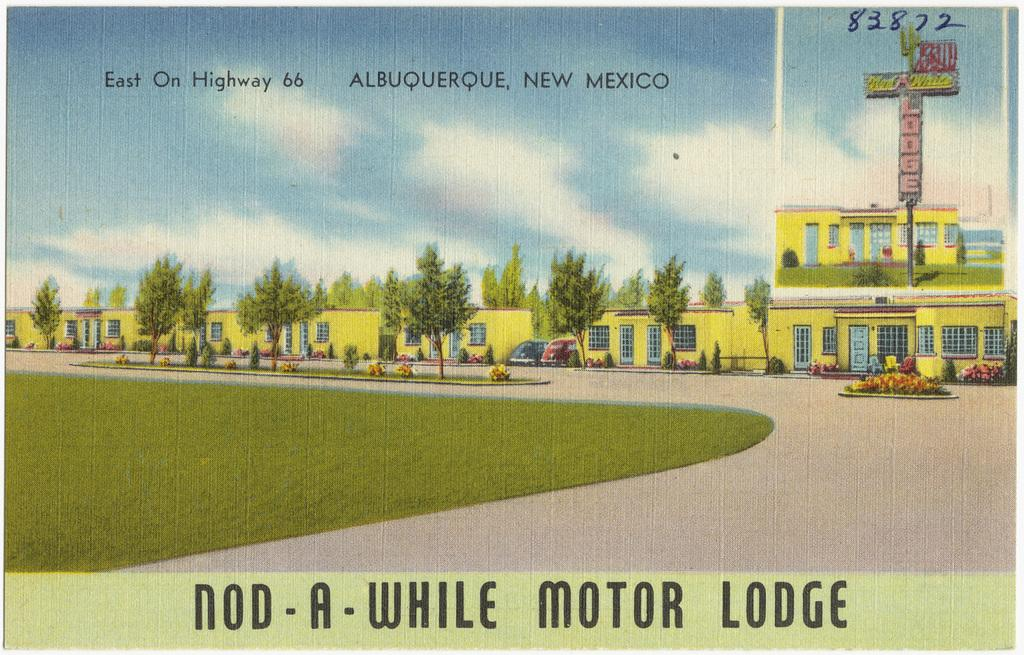Provide a one-sentence caption for the provided image. Postcard showing a row of yellow bulidings and "Nod-A-While Motor Lodge" near the bottom. 